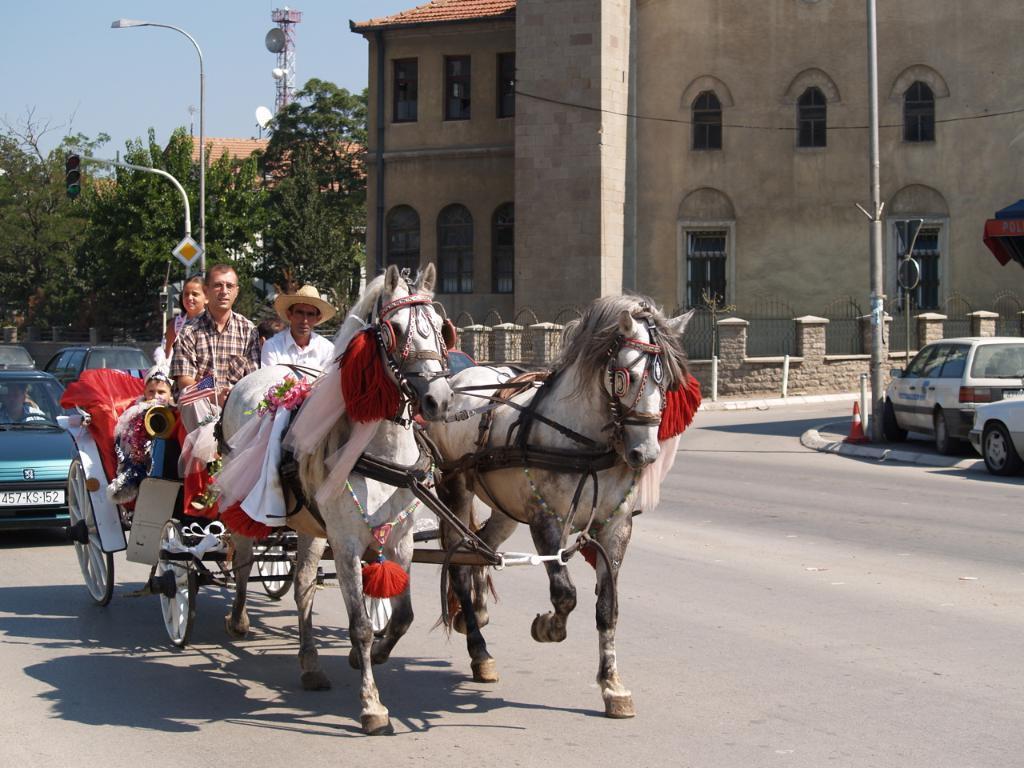Describe this image in one or two sentences. In this image we can see there are two horses in the foreground also we see some vehicle on the ground. 